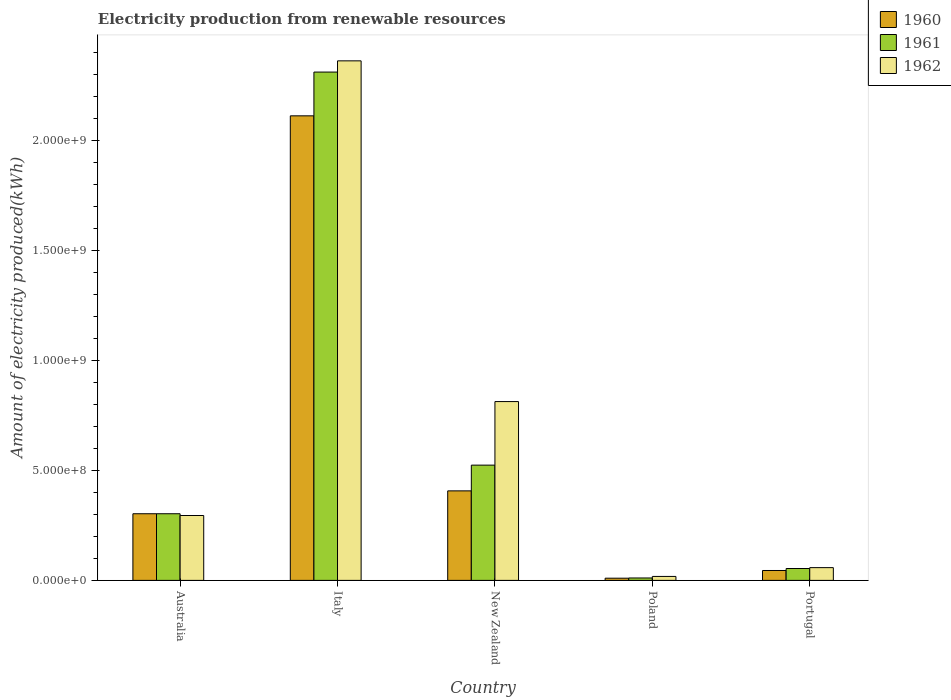How many different coloured bars are there?
Offer a terse response. 3. How many groups of bars are there?
Provide a short and direct response. 5. How many bars are there on the 4th tick from the left?
Your response must be concise. 3. What is the label of the 2nd group of bars from the left?
Give a very brief answer. Italy. What is the amount of electricity produced in 1960 in Italy?
Make the answer very short. 2.11e+09. Across all countries, what is the maximum amount of electricity produced in 1960?
Provide a succinct answer. 2.11e+09. Across all countries, what is the minimum amount of electricity produced in 1962?
Make the answer very short. 1.80e+07. What is the total amount of electricity produced in 1961 in the graph?
Keep it short and to the point. 3.20e+09. What is the difference between the amount of electricity produced in 1960 in New Zealand and that in Poland?
Ensure brevity in your answer.  3.97e+08. What is the difference between the amount of electricity produced in 1960 in New Zealand and the amount of electricity produced in 1961 in Poland?
Keep it short and to the point. 3.96e+08. What is the average amount of electricity produced in 1961 per country?
Your answer should be compact. 6.41e+08. What is the difference between the amount of electricity produced of/in 1961 and amount of electricity produced of/in 1962 in Italy?
Provide a succinct answer. -5.10e+07. In how many countries, is the amount of electricity produced in 1961 greater than 1500000000 kWh?
Provide a short and direct response. 1. What is the ratio of the amount of electricity produced in 1961 in Australia to that in Italy?
Ensure brevity in your answer.  0.13. Is the amount of electricity produced in 1960 in Italy less than that in Portugal?
Your response must be concise. No. Is the difference between the amount of electricity produced in 1961 in Australia and Portugal greater than the difference between the amount of electricity produced in 1962 in Australia and Portugal?
Your answer should be very brief. Yes. What is the difference between the highest and the second highest amount of electricity produced in 1962?
Your answer should be very brief. 1.55e+09. What is the difference between the highest and the lowest amount of electricity produced in 1962?
Your response must be concise. 2.34e+09. In how many countries, is the amount of electricity produced in 1962 greater than the average amount of electricity produced in 1962 taken over all countries?
Give a very brief answer. 2. Are the values on the major ticks of Y-axis written in scientific E-notation?
Ensure brevity in your answer.  Yes. Does the graph contain grids?
Make the answer very short. No. Where does the legend appear in the graph?
Give a very brief answer. Top right. How many legend labels are there?
Your response must be concise. 3. What is the title of the graph?
Your answer should be compact. Electricity production from renewable resources. Does "1984" appear as one of the legend labels in the graph?
Provide a succinct answer. No. What is the label or title of the X-axis?
Ensure brevity in your answer.  Country. What is the label or title of the Y-axis?
Provide a short and direct response. Amount of electricity produced(kWh). What is the Amount of electricity produced(kWh) of 1960 in Australia?
Give a very brief answer. 3.03e+08. What is the Amount of electricity produced(kWh) of 1961 in Australia?
Your answer should be very brief. 3.03e+08. What is the Amount of electricity produced(kWh) of 1962 in Australia?
Keep it short and to the point. 2.95e+08. What is the Amount of electricity produced(kWh) in 1960 in Italy?
Offer a very short reply. 2.11e+09. What is the Amount of electricity produced(kWh) in 1961 in Italy?
Your response must be concise. 2.31e+09. What is the Amount of electricity produced(kWh) of 1962 in Italy?
Provide a short and direct response. 2.36e+09. What is the Amount of electricity produced(kWh) in 1960 in New Zealand?
Give a very brief answer. 4.07e+08. What is the Amount of electricity produced(kWh) in 1961 in New Zealand?
Your answer should be compact. 5.24e+08. What is the Amount of electricity produced(kWh) of 1962 in New Zealand?
Give a very brief answer. 8.13e+08. What is the Amount of electricity produced(kWh) in 1961 in Poland?
Make the answer very short. 1.10e+07. What is the Amount of electricity produced(kWh) in 1962 in Poland?
Your response must be concise. 1.80e+07. What is the Amount of electricity produced(kWh) of 1960 in Portugal?
Keep it short and to the point. 4.50e+07. What is the Amount of electricity produced(kWh) of 1961 in Portugal?
Give a very brief answer. 5.40e+07. What is the Amount of electricity produced(kWh) of 1962 in Portugal?
Provide a short and direct response. 5.80e+07. Across all countries, what is the maximum Amount of electricity produced(kWh) in 1960?
Ensure brevity in your answer.  2.11e+09. Across all countries, what is the maximum Amount of electricity produced(kWh) of 1961?
Give a very brief answer. 2.31e+09. Across all countries, what is the maximum Amount of electricity produced(kWh) in 1962?
Ensure brevity in your answer.  2.36e+09. Across all countries, what is the minimum Amount of electricity produced(kWh) in 1961?
Your answer should be compact. 1.10e+07. Across all countries, what is the minimum Amount of electricity produced(kWh) of 1962?
Your answer should be compact. 1.80e+07. What is the total Amount of electricity produced(kWh) in 1960 in the graph?
Ensure brevity in your answer.  2.88e+09. What is the total Amount of electricity produced(kWh) in 1961 in the graph?
Provide a short and direct response. 3.20e+09. What is the total Amount of electricity produced(kWh) in 1962 in the graph?
Keep it short and to the point. 3.55e+09. What is the difference between the Amount of electricity produced(kWh) in 1960 in Australia and that in Italy?
Give a very brief answer. -1.81e+09. What is the difference between the Amount of electricity produced(kWh) in 1961 in Australia and that in Italy?
Your response must be concise. -2.01e+09. What is the difference between the Amount of electricity produced(kWh) of 1962 in Australia and that in Italy?
Offer a very short reply. -2.07e+09. What is the difference between the Amount of electricity produced(kWh) in 1960 in Australia and that in New Zealand?
Provide a short and direct response. -1.04e+08. What is the difference between the Amount of electricity produced(kWh) of 1961 in Australia and that in New Zealand?
Offer a terse response. -2.21e+08. What is the difference between the Amount of electricity produced(kWh) of 1962 in Australia and that in New Zealand?
Your answer should be compact. -5.18e+08. What is the difference between the Amount of electricity produced(kWh) of 1960 in Australia and that in Poland?
Your response must be concise. 2.93e+08. What is the difference between the Amount of electricity produced(kWh) in 1961 in Australia and that in Poland?
Offer a terse response. 2.92e+08. What is the difference between the Amount of electricity produced(kWh) of 1962 in Australia and that in Poland?
Provide a short and direct response. 2.77e+08. What is the difference between the Amount of electricity produced(kWh) in 1960 in Australia and that in Portugal?
Your answer should be compact. 2.58e+08. What is the difference between the Amount of electricity produced(kWh) of 1961 in Australia and that in Portugal?
Provide a short and direct response. 2.49e+08. What is the difference between the Amount of electricity produced(kWh) in 1962 in Australia and that in Portugal?
Offer a terse response. 2.37e+08. What is the difference between the Amount of electricity produced(kWh) of 1960 in Italy and that in New Zealand?
Offer a terse response. 1.70e+09. What is the difference between the Amount of electricity produced(kWh) in 1961 in Italy and that in New Zealand?
Your response must be concise. 1.79e+09. What is the difference between the Amount of electricity produced(kWh) of 1962 in Italy and that in New Zealand?
Keep it short and to the point. 1.55e+09. What is the difference between the Amount of electricity produced(kWh) of 1960 in Italy and that in Poland?
Make the answer very short. 2.10e+09. What is the difference between the Amount of electricity produced(kWh) in 1961 in Italy and that in Poland?
Your answer should be compact. 2.30e+09. What is the difference between the Amount of electricity produced(kWh) of 1962 in Italy and that in Poland?
Provide a succinct answer. 2.34e+09. What is the difference between the Amount of electricity produced(kWh) in 1960 in Italy and that in Portugal?
Offer a very short reply. 2.07e+09. What is the difference between the Amount of electricity produced(kWh) in 1961 in Italy and that in Portugal?
Your response must be concise. 2.26e+09. What is the difference between the Amount of electricity produced(kWh) of 1962 in Italy and that in Portugal?
Your response must be concise. 2.30e+09. What is the difference between the Amount of electricity produced(kWh) of 1960 in New Zealand and that in Poland?
Keep it short and to the point. 3.97e+08. What is the difference between the Amount of electricity produced(kWh) of 1961 in New Zealand and that in Poland?
Provide a succinct answer. 5.13e+08. What is the difference between the Amount of electricity produced(kWh) of 1962 in New Zealand and that in Poland?
Provide a succinct answer. 7.95e+08. What is the difference between the Amount of electricity produced(kWh) in 1960 in New Zealand and that in Portugal?
Ensure brevity in your answer.  3.62e+08. What is the difference between the Amount of electricity produced(kWh) in 1961 in New Zealand and that in Portugal?
Give a very brief answer. 4.70e+08. What is the difference between the Amount of electricity produced(kWh) in 1962 in New Zealand and that in Portugal?
Keep it short and to the point. 7.55e+08. What is the difference between the Amount of electricity produced(kWh) in 1960 in Poland and that in Portugal?
Your answer should be very brief. -3.50e+07. What is the difference between the Amount of electricity produced(kWh) of 1961 in Poland and that in Portugal?
Ensure brevity in your answer.  -4.30e+07. What is the difference between the Amount of electricity produced(kWh) of 1962 in Poland and that in Portugal?
Make the answer very short. -4.00e+07. What is the difference between the Amount of electricity produced(kWh) of 1960 in Australia and the Amount of electricity produced(kWh) of 1961 in Italy?
Your answer should be very brief. -2.01e+09. What is the difference between the Amount of electricity produced(kWh) in 1960 in Australia and the Amount of electricity produced(kWh) in 1962 in Italy?
Provide a short and direct response. -2.06e+09. What is the difference between the Amount of electricity produced(kWh) in 1961 in Australia and the Amount of electricity produced(kWh) in 1962 in Italy?
Give a very brief answer. -2.06e+09. What is the difference between the Amount of electricity produced(kWh) of 1960 in Australia and the Amount of electricity produced(kWh) of 1961 in New Zealand?
Make the answer very short. -2.21e+08. What is the difference between the Amount of electricity produced(kWh) of 1960 in Australia and the Amount of electricity produced(kWh) of 1962 in New Zealand?
Your response must be concise. -5.10e+08. What is the difference between the Amount of electricity produced(kWh) in 1961 in Australia and the Amount of electricity produced(kWh) in 1962 in New Zealand?
Keep it short and to the point. -5.10e+08. What is the difference between the Amount of electricity produced(kWh) in 1960 in Australia and the Amount of electricity produced(kWh) in 1961 in Poland?
Make the answer very short. 2.92e+08. What is the difference between the Amount of electricity produced(kWh) of 1960 in Australia and the Amount of electricity produced(kWh) of 1962 in Poland?
Give a very brief answer. 2.85e+08. What is the difference between the Amount of electricity produced(kWh) of 1961 in Australia and the Amount of electricity produced(kWh) of 1962 in Poland?
Make the answer very short. 2.85e+08. What is the difference between the Amount of electricity produced(kWh) in 1960 in Australia and the Amount of electricity produced(kWh) in 1961 in Portugal?
Your answer should be compact. 2.49e+08. What is the difference between the Amount of electricity produced(kWh) of 1960 in Australia and the Amount of electricity produced(kWh) of 1962 in Portugal?
Offer a very short reply. 2.45e+08. What is the difference between the Amount of electricity produced(kWh) of 1961 in Australia and the Amount of electricity produced(kWh) of 1962 in Portugal?
Offer a terse response. 2.45e+08. What is the difference between the Amount of electricity produced(kWh) of 1960 in Italy and the Amount of electricity produced(kWh) of 1961 in New Zealand?
Make the answer very short. 1.59e+09. What is the difference between the Amount of electricity produced(kWh) in 1960 in Italy and the Amount of electricity produced(kWh) in 1962 in New Zealand?
Your answer should be very brief. 1.30e+09. What is the difference between the Amount of electricity produced(kWh) of 1961 in Italy and the Amount of electricity produced(kWh) of 1962 in New Zealand?
Offer a very short reply. 1.50e+09. What is the difference between the Amount of electricity produced(kWh) of 1960 in Italy and the Amount of electricity produced(kWh) of 1961 in Poland?
Your response must be concise. 2.10e+09. What is the difference between the Amount of electricity produced(kWh) in 1960 in Italy and the Amount of electricity produced(kWh) in 1962 in Poland?
Your response must be concise. 2.09e+09. What is the difference between the Amount of electricity produced(kWh) in 1961 in Italy and the Amount of electricity produced(kWh) in 1962 in Poland?
Offer a very short reply. 2.29e+09. What is the difference between the Amount of electricity produced(kWh) in 1960 in Italy and the Amount of electricity produced(kWh) in 1961 in Portugal?
Make the answer very short. 2.06e+09. What is the difference between the Amount of electricity produced(kWh) in 1960 in Italy and the Amount of electricity produced(kWh) in 1962 in Portugal?
Ensure brevity in your answer.  2.05e+09. What is the difference between the Amount of electricity produced(kWh) of 1961 in Italy and the Amount of electricity produced(kWh) of 1962 in Portugal?
Your answer should be very brief. 2.25e+09. What is the difference between the Amount of electricity produced(kWh) of 1960 in New Zealand and the Amount of electricity produced(kWh) of 1961 in Poland?
Ensure brevity in your answer.  3.96e+08. What is the difference between the Amount of electricity produced(kWh) in 1960 in New Zealand and the Amount of electricity produced(kWh) in 1962 in Poland?
Make the answer very short. 3.89e+08. What is the difference between the Amount of electricity produced(kWh) of 1961 in New Zealand and the Amount of electricity produced(kWh) of 1962 in Poland?
Ensure brevity in your answer.  5.06e+08. What is the difference between the Amount of electricity produced(kWh) of 1960 in New Zealand and the Amount of electricity produced(kWh) of 1961 in Portugal?
Your response must be concise. 3.53e+08. What is the difference between the Amount of electricity produced(kWh) in 1960 in New Zealand and the Amount of electricity produced(kWh) in 1962 in Portugal?
Make the answer very short. 3.49e+08. What is the difference between the Amount of electricity produced(kWh) of 1961 in New Zealand and the Amount of electricity produced(kWh) of 1962 in Portugal?
Keep it short and to the point. 4.66e+08. What is the difference between the Amount of electricity produced(kWh) of 1960 in Poland and the Amount of electricity produced(kWh) of 1961 in Portugal?
Provide a short and direct response. -4.40e+07. What is the difference between the Amount of electricity produced(kWh) of 1960 in Poland and the Amount of electricity produced(kWh) of 1962 in Portugal?
Ensure brevity in your answer.  -4.80e+07. What is the difference between the Amount of electricity produced(kWh) in 1961 in Poland and the Amount of electricity produced(kWh) in 1962 in Portugal?
Your response must be concise. -4.70e+07. What is the average Amount of electricity produced(kWh) of 1960 per country?
Offer a terse response. 5.75e+08. What is the average Amount of electricity produced(kWh) in 1961 per country?
Offer a very short reply. 6.41e+08. What is the average Amount of electricity produced(kWh) in 1962 per country?
Offer a very short reply. 7.09e+08. What is the difference between the Amount of electricity produced(kWh) of 1960 and Amount of electricity produced(kWh) of 1962 in Australia?
Keep it short and to the point. 8.00e+06. What is the difference between the Amount of electricity produced(kWh) in 1961 and Amount of electricity produced(kWh) in 1962 in Australia?
Ensure brevity in your answer.  8.00e+06. What is the difference between the Amount of electricity produced(kWh) of 1960 and Amount of electricity produced(kWh) of 1961 in Italy?
Make the answer very short. -1.99e+08. What is the difference between the Amount of electricity produced(kWh) of 1960 and Amount of electricity produced(kWh) of 1962 in Italy?
Provide a short and direct response. -2.50e+08. What is the difference between the Amount of electricity produced(kWh) in 1961 and Amount of electricity produced(kWh) in 1962 in Italy?
Provide a succinct answer. -5.10e+07. What is the difference between the Amount of electricity produced(kWh) in 1960 and Amount of electricity produced(kWh) in 1961 in New Zealand?
Your response must be concise. -1.17e+08. What is the difference between the Amount of electricity produced(kWh) in 1960 and Amount of electricity produced(kWh) in 1962 in New Zealand?
Keep it short and to the point. -4.06e+08. What is the difference between the Amount of electricity produced(kWh) of 1961 and Amount of electricity produced(kWh) of 1962 in New Zealand?
Offer a terse response. -2.89e+08. What is the difference between the Amount of electricity produced(kWh) of 1960 and Amount of electricity produced(kWh) of 1961 in Poland?
Your answer should be very brief. -1.00e+06. What is the difference between the Amount of electricity produced(kWh) of 1960 and Amount of electricity produced(kWh) of 1962 in Poland?
Your response must be concise. -8.00e+06. What is the difference between the Amount of electricity produced(kWh) in 1961 and Amount of electricity produced(kWh) in 1962 in Poland?
Provide a succinct answer. -7.00e+06. What is the difference between the Amount of electricity produced(kWh) in 1960 and Amount of electricity produced(kWh) in 1961 in Portugal?
Provide a succinct answer. -9.00e+06. What is the difference between the Amount of electricity produced(kWh) in 1960 and Amount of electricity produced(kWh) in 1962 in Portugal?
Offer a terse response. -1.30e+07. What is the difference between the Amount of electricity produced(kWh) of 1961 and Amount of electricity produced(kWh) of 1962 in Portugal?
Give a very brief answer. -4.00e+06. What is the ratio of the Amount of electricity produced(kWh) of 1960 in Australia to that in Italy?
Offer a very short reply. 0.14. What is the ratio of the Amount of electricity produced(kWh) of 1961 in Australia to that in Italy?
Offer a very short reply. 0.13. What is the ratio of the Amount of electricity produced(kWh) in 1962 in Australia to that in Italy?
Give a very brief answer. 0.12. What is the ratio of the Amount of electricity produced(kWh) in 1960 in Australia to that in New Zealand?
Your answer should be very brief. 0.74. What is the ratio of the Amount of electricity produced(kWh) of 1961 in Australia to that in New Zealand?
Your response must be concise. 0.58. What is the ratio of the Amount of electricity produced(kWh) in 1962 in Australia to that in New Zealand?
Give a very brief answer. 0.36. What is the ratio of the Amount of electricity produced(kWh) of 1960 in Australia to that in Poland?
Ensure brevity in your answer.  30.3. What is the ratio of the Amount of electricity produced(kWh) in 1961 in Australia to that in Poland?
Your answer should be compact. 27.55. What is the ratio of the Amount of electricity produced(kWh) of 1962 in Australia to that in Poland?
Provide a short and direct response. 16.39. What is the ratio of the Amount of electricity produced(kWh) in 1960 in Australia to that in Portugal?
Keep it short and to the point. 6.73. What is the ratio of the Amount of electricity produced(kWh) in 1961 in Australia to that in Portugal?
Provide a short and direct response. 5.61. What is the ratio of the Amount of electricity produced(kWh) of 1962 in Australia to that in Portugal?
Your answer should be compact. 5.09. What is the ratio of the Amount of electricity produced(kWh) in 1960 in Italy to that in New Zealand?
Keep it short and to the point. 5.19. What is the ratio of the Amount of electricity produced(kWh) in 1961 in Italy to that in New Zealand?
Provide a succinct answer. 4.41. What is the ratio of the Amount of electricity produced(kWh) of 1962 in Italy to that in New Zealand?
Offer a very short reply. 2.91. What is the ratio of the Amount of electricity produced(kWh) of 1960 in Italy to that in Poland?
Your answer should be very brief. 211.2. What is the ratio of the Amount of electricity produced(kWh) in 1961 in Italy to that in Poland?
Provide a succinct answer. 210.09. What is the ratio of the Amount of electricity produced(kWh) in 1962 in Italy to that in Poland?
Your answer should be very brief. 131.22. What is the ratio of the Amount of electricity produced(kWh) of 1960 in Italy to that in Portugal?
Your response must be concise. 46.93. What is the ratio of the Amount of electricity produced(kWh) of 1961 in Italy to that in Portugal?
Make the answer very short. 42.8. What is the ratio of the Amount of electricity produced(kWh) in 1962 in Italy to that in Portugal?
Ensure brevity in your answer.  40.72. What is the ratio of the Amount of electricity produced(kWh) of 1960 in New Zealand to that in Poland?
Give a very brief answer. 40.7. What is the ratio of the Amount of electricity produced(kWh) of 1961 in New Zealand to that in Poland?
Keep it short and to the point. 47.64. What is the ratio of the Amount of electricity produced(kWh) of 1962 in New Zealand to that in Poland?
Keep it short and to the point. 45.17. What is the ratio of the Amount of electricity produced(kWh) of 1960 in New Zealand to that in Portugal?
Give a very brief answer. 9.04. What is the ratio of the Amount of electricity produced(kWh) of 1961 in New Zealand to that in Portugal?
Give a very brief answer. 9.7. What is the ratio of the Amount of electricity produced(kWh) of 1962 in New Zealand to that in Portugal?
Make the answer very short. 14.02. What is the ratio of the Amount of electricity produced(kWh) in 1960 in Poland to that in Portugal?
Your response must be concise. 0.22. What is the ratio of the Amount of electricity produced(kWh) in 1961 in Poland to that in Portugal?
Keep it short and to the point. 0.2. What is the ratio of the Amount of electricity produced(kWh) of 1962 in Poland to that in Portugal?
Make the answer very short. 0.31. What is the difference between the highest and the second highest Amount of electricity produced(kWh) in 1960?
Your answer should be very brief. 1.70e+09. What is the difference between the highest and the second highest Amount of electricity produced(kWh) of 1961?
Give a very brief answer. 1.79e+09. What is the difference between the highest and the second highest Amount of electricity produced(kWh) in 1962?
Make the answer very short. 1.55e+09. What is the difference between the highest and the lowest Amount of electricity produced(kWh) in 1960?
Your response must be concise. 2.10e+09. What is the difference between the highest and the lowest Amount of electricity produced(kWh) of 1961?
Offer a terse response. 2.30e+09. What is the difference between the highest and the lowest Amount of electricity produced(kWh) of 1962?
Provide a short and direct response. 2.34e+09. 